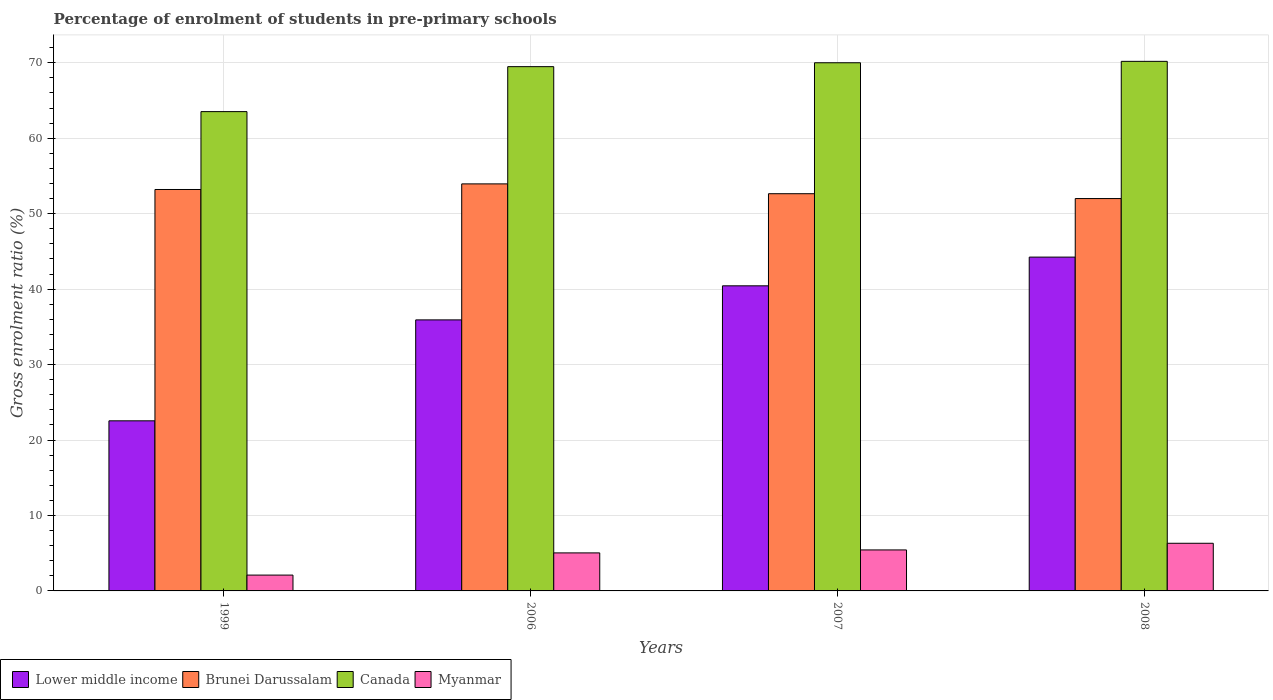How many different coloured bars are there?
Make the answer very short. 4. Are the number of bars per tick equal to the number of legend labels?
Ensure brevity in your answer.  Yes. Are the number of bars on each tick of the X-axis equal?
Your answer should be very brief. Yes. How many bars are there on the 1st tick from the left?
Keep it short and to the point. 4. In how many cases, is the number of bars for a given year not equal to the number of legend labels?
Make the answer very short. 0. What is the percentage of students enrolled in pre-primary schools in Canada in 2007?
Your answer should be very brief. 70. Across all years, what is the maximum percentage of students enrolled in pre-primary schools in Canada?
Your response must be concise. 70.18. Across all years, what is the minimum percentage of students enrolled in pre-primary schools in Lower middle income?
Make the answer very short. 22.54. In which year was the percentage of students enrolled in pre-primary schools in Canada minimum?
Your answer should be compact. 1999. What is the total percentage of students enrolled in pre-primary schools in Canada in the graph?
Your response must be concise. 273.19. What is the difference between the percentage of students enrolled in pre-primary schools in Lower middle income in 2006 and that in 2007?
Provide a succinct answer. -4.51. What is the difference between the percentage of students enrolled in pre-primary schools in Brunei Darussalam in 2007 and the percentage of students enrolled in pre-primary schools in Lower middle income in 2006?
Offer a terse response. 16.72. What is the average percentage of students enrolled in pre-primary schools in Myanmar per year?
Offer a very short reply. 4.72. In the year 2007, what is the difference between the percentage of students enrolled in pre-primary schools in Brunei Darussalam and percentage of students enrolled in pre-primary schools in Canada?
Keep it short and to the point. -17.35. In how many years, is the percentage of students enrolled in pre-primary schools in Canada greater than 6 %?
Offer a terse response. 4. What is the ratio of the percentage of students enrolled in pre-primary schools in Canada in 1999 to that in 2007?
Provide a succinct answer. 0.91. Is the difference between the percentage of students enrolled in pre-primary schools in Brunei Darussalam in 2007 and 2008 greater than the difference between the percentage of students enrolled in pre-primary schools in Canada in 2007 and 2008?
Give a very brief answer. Yes. What is the difference between the highest and the second highest percentage of students enrolled in pre-primary schools in Lower middle income?
Provide a succinct answer. 3.8. What is the difference between the highest and the lowest percentage of students enrolled in pre-primary schools in Brunei Darussalam?
Your answer should be very brief. 1.94. In how many years, is the percentage of students enrolled in pre-primary schools in Myanmar greater than the average percentage of students enrolled in pre-primary schools in Myanmar taken over all years?
Your response must be concise. 3. Is the sum of the percentage of students enrolled in pre-primary schools in Canada in 2007 and 2008 greater than the maximum percentage of students enrolled in pre-primary schools in Myanmar across all years?
Provide a succinct answer. Yes. Is it the case that in every year, the sum of the percentage of students enrolled in pre-primary schools in Brunei Darussalam and percentage of students enrolled in pre-primary schools in Canada is greater than the sum of percentage of students enrolled in pre-primary schools in Myanmar and percentage of students enrolled in pre-primary schools in Lower middle income?
Your answer should be very brief. No. What does the 4th bar from the left in 2008 represents?
Keep it short and to the point. Myanmar. What does the 2nd bar from the right in 2007 represents?
Provide a short and direct response. Canada. How many bars are there?
Ensure brevity in your answer.  16. Are all the bars in the graph horizontal?
Offer a very short reply. No. What is the difference between two consecutive major ticks on the Y-axis?
Offer a very short reply. 10. Are the values on the major ticks of Y-axis written in scientific E-notation?
Your response must be concise. No. Does the graph contain grids?
Offer a very short reply. Yes. Where does the legend appear in the graph?
Your answer should be very brief. Bottom left. What is the title of the graph?
Keep it short and to the point. Percentage of enrolment of students in pre-primary schools. What is the Gross enrolment ratio (%) of Lower middle income in 1999?
Provide a short and direct response. 22.54. What is the Gross enrolment ratio (%) of Brunei Darussalam in 1999?
Make the answer very short. 53.2. What is the Gross enrolment ratio (%) in Canada in 1999?
Keep it short and to the point. 63.52. What is the Gross enrolment ratio (%) in Myanmar in 1999?
Offer a terse response. 2.1. What is the Gross enrolment ratio (%) in Lower middle income in 2006?
Give a very brief answer. 35.92. What is the Gross enrolment ratio (%) in Brunei Darussalam in 2006?
Your answer should be very brief. 53.94. What is the Gross enrolment ratio (%) in Canada in 2006?
Your response must be concise. 69.48. What is the Gross enrolment ratio (%) of Myanmar in 2006?
Your answer should be compact. 5.04. What is the Gross enrolment ratio (%) of Lower middle income in 2007?
Your answer should be very brief. 40.44. What is the Gross enrolment ratio (%) in Brunei Darussalam in 2007?
Make the answer very short. 52.64. What is the Gross enrolment ratio (%) in Canada in 2007?
Your answer should be compact. 70. What is the Gross enrolment ratio (%) of Myanmar in 2007?
Keep it short and to the point. 5.43. What is the Gross enrolment ratio (%) in Lower middle income in 2008?
Ensure brevity in your answer.  44.24. What is the Gross enrolment ratio (%) of Brunei Darussalam in 2008?
Provide a succinct answer. 52. What is the Gross enrolment ratio (%) in Canada in 2008?
Your answer should be compact. 70.18. What is the Gross enrolment ratio (%) in Myanmar in 2008?
Give a very brief answer. 6.31. Across all years, what is the maximum Gross enrolment ratio (%) of Lower middle income?
Offer a terse response. 44.24. Across all years, what is the maximum Gross enrolment ratio (%) of Brunei Darussalam?
Make the answer very short. 53.94. Across all years, what is the maximum Gross enrolment ratio (%) in Canada?
Your answer should be very brief. 70.18. Across all years, what is the maximum Gross enrolment ratio (%) of Myanmar?
Ensure brevity in your answer.  6.31. Across all years, what is the minimum Gross enrolment ratio (%) in Lower middle income?
Provide a short and direct response. 22.54. Across all years, what is the minimum Gross enrolment ratio (%) of Brunei Darussalam?
Ensure brevity in your answer.  52. Across all years, what is the minimum Gross enrolment ratio (%) of Canada?
Ensure brevity in your answer.  63.52. Across all years, what is the minimum Gross enrolment ratio (%) in Myanmar?
Your answer should be very brief. 2.1. What is the total Gross enrolment ratio (%) in Lower middle income in the graph?
Your answer should be compact. 143.14. What is the total Gross enrolment ratio (%) of Brunei Darussalam in the graph?
Offer a terse response. 211.79. What is the total Gross enrolment ratio (%) in Canada in the graph?
Your answer should be very brief. 273.19. What is the total Gross enrolment ratio (%) in Myanmar in the graph?
Your answer should be compact. 18.89. What is the difference between the Gross enrolment ratio (%) of Lower middle income in 1999 and that in 2006?
Make the answer very short. -13.38. What is the difference between the Gross enrolment ratio (%) of Brunei Darussalam in 1999 and that in 2006?
Make the answer very short. -0.74. What is the difference between the Gross enrolment ratio (%) of Canada in 1999 and that in 2006?
Give a very brief answer. -5.96. What is the difference between the Gross enrolment ratio (%) of Myanmar in 1999 and that in 2006?
Provide a short and direct response. -2.94. What is the difference between the Gross enrolment ratio (%) of Lower middle income in 1999 and that in 2007?
Keep it short and to the point. -17.89. What is the difference between the Gross enrolment ratio (%) of Brunei Darussalam in 1999 and that in 2007?
Offer a terse response. 0.56. What is the difference between the Gross enrolment ratio (%) of Canada in 1999 and that in 2007?
Your answer should be compact. -6.48. What is the difference between the Gross enrolment ratio (%) of Myanmar in 1999 and that in 2007?
Provide a short and direct response. -3.33. What is the difference between the Gross enrolment ratio (%) in Lower middle income in 1999 and that in 2008?
Give a very brief answer. -21.7. What is the difference between the Gross enrolment ratio (%) of Brunei Darussalam in 1999 and that in 2008?
Your response must be concise. 1.2. What is the difference between the Gross enrolment ratio (%) in Canada in 1999 and that in 2008?
Provide a short and direct response. -6.66. What is the difference between the Gross enrolment ratio (%) in Myanmar in 1999 and that in 2008?
Give a very brief answer. -4.21. What is the difference between the Gross enrolment ratio (%) in Lower middle income in 2006 and that in 2007?
Provide a short and direct response. -4.51. What is the difference between the Gross enrolment ratio (%) in Brunei Darussalam in 2006 and that in 2007?
Offer a terse response. 1.3. What is the difference between the Gross enrolment ratio (%) in Canada in 2006 and that in 2007?
Your answer should be very brief. -0.51. What is the difference between the Gross enrolment ratio (%) of Myanmar in 2006 and that in 2007?
Make the answer very short. -0.39. What is the difference between the Gross enrolment ratio (%) of Lower middle income in 2006 and that in 2008?
Keep it short and to the point. -8.32. What is the difference between the Gross enrolment ratio (%) of Brunei Darussalam in 2006 and that in 2008?
Provide a succinct answer. 1.94. What is the difference between the Gross enrolment ratio (%) in Canada in 2006 and that in 2008?
Keep it short and to the point. -0.7. What is the difference between the Gross enrolment ratio (%) of Myanmar in 2006 and that in 2008?
Your response must be concise. -1.27. What is the difference between the Gross enrolment ratio (%) of Lower middle income in 2007 and that in 2008?
Keep it short and to the point. -3.8. What is the difference between the Gross enrolment ratio (%) of Brunei Darussalam in 2007 and that in 2008?
Provide a short and direct response. 0.64. What is the difference between the Gross enrolment ratio (%) in Canada in 2007 and that in 2008?
Make the answer very short. -0.19. What is the difference between the Gross enrolment ratio (%) of Myanmar in 2007 and that in 2008?
Keep it short and to the point. -0.88. What is the difference between the Gross enrolment ratio (%) of Lower middle income in 1999 and the Gross enrolment ratio (%) of Brunei Darussalam in 2006?
Give a very brief answer. -31.4. What is the difference between the Gross enrolment ratio (%) of Lower middle income in 1999 and the Gross enrolment ratio (%) of Canada in 2006?
Offer a terse response. -46.94. What is the difference between the Gross enrolment ratio (%) in Lower middle income in 1999 and the Gross enrolment ratio (%) in Myanmar in 2006?
Provide a short and direct response. 17.5. What is the difference between the Gross enrolment ratio (%) in Brunei Darussalam in 1999 and the Gross enrolment ratio (%) in Canada in 2006?
Your answer should be very brief. -16.28. What is the difference between the Gross enrolment ratio (%) in Brunei Darussalam in 1999 and the Gross enrolment ratio (%) in Myanmar in 2006?
Offer a terse response. 48.16. What is the difference between the Gross enrolment ratio (%) of Canada in 1999 and the Gross enrolment ratio (%) of Myanmar in 2006?
Offer a terse response. 58.48. What is the difference between the Gross enrolment ratio (%) of Lower middle income in 1999 and the Gross enrolment ratio (%) of Brunei Darussalam in 2007?
Give a very brief answer. -30.1. What is the difference between the Gross enrolment ratio (%) in Lower middle income in 1999 and the Gross enrolment ratio (%) in Canada in 2007?
Provide a short and direct response. -47.45. What is the difference between the Gross enrolment ratio (%) of Lower middle income in 1999 and the Gross enrolment ratio (%) of Myanmar in 2007?
Your answer should be very brief. 17.11. What is the difference between the Gross enrolment ratio (%) of Brunei Darussalam in 1999 and the Gross enrolment ratio (%) of Canada in 2007?
Provide a succinct answer. -16.8. What is the difference between the Gross enrolment ratio (%) of Brunei Darussalam in 1999 and the Gross enrolment ratio (%) of Myanmar in 2007?
Your answer should be very brief. 47.77. What is the difference between the Gross enrolment ratio (%) in Canada in 1999 and the Gross enrolment ratio (%) in Myanmar in 2007?
Provide a succinct answer. 58.09. What is the difference between the Gross enrolment ratio (%) in Lower middle income in 1999 and the Gross enrolment ratio (%) in Brunei Darussalam in 2008?
Your answer should be compact. -29.46. What is the difference between the Gross enrolment ratio (%) of Lower middle income in 1999 and the Gross enrolment ratio (%) of Canada in 2008?
Your answer should be very brief. -47.64. What is the difference between the Gross enrolment ratio (%) in Lower middle income in 1999 and the Gross enrolment ratio (%) in Myanmar in 2008?
Provide a short and direct response. 16.23. What is the difference between the Gross enrolment ratio (%) of Brunei Darussalam in 1999 and the Gross enrolment ratio (%) of Canada in 2008?
Offer a terse response. -16.98. What is the difference between the Gross enrolment ratio (%) in Brunei Darussalam in 1999 and the Gross enrolment ratio (%) in Myanmar in 2008?
Offer a terse response. 46.89. What is the difference between the Gross enrolment ratio (%) in Canada in 1999 and the Gross enrolment ratio (%) in Myanmar in 2008?
Make the answer very short. 57.21. What is the difference between the Gross enrolment ratio (%) in Lower middle income in 2006 and the Gross enrolment ratio (%) in Brunei Darussalam in 2007?
Your response must be concise. -16.72. What is the difference between the Gross enrolment ratio (%) of Lower middle income in 2006 and the Gross enrolment ratio (%) of Canada in 2007?
Ensure brevity in your answer.  -34.08. What is the difference between the Gross enrolment ratio (%) in Lower middle income in 2006 and the Gross enrolment ratio (%) in Myanmar in 2007?
Offer a terse response. 30.49. What is the difference between the Gross enrolment ratio (%) in Brunei Darussalam in 2006 and the Gross enrolment ratio (%) in Canada in 2007?
Provide a succinct answer. -16.05. What is the difference between the Gross enrolment ratio (%) in Brunei Darussalam in 2006 and the Gross enrolment ratio (%) in Myanmar in 2007?
Keep it short and to the point. 48.51. What is the difference between the Gross enrolment ratio (%) in Canada in 2006 and the Gross enrolment ratio (%) in Myanmar in 2007?
Give a very brief answer. 64.05. What is the difference between the Gross enrolment ratio (%) of Lower middle income in 2006 and the Gross enrolment ratio (%) of Brunei Darussalam in 2008?
Your answer should be compact. -16.08. What is the difference between the Gross enrolment ratio (%) of Lower middle income in 2006 and the Gross enrolment ratio (%) of Canada in 2008?
Make the answer very short. -34.26. What is the difference between the Gross enrolment ratio (%) in Lower middle income in 2006 and the Gross enrolment ratio (%) in Myanmar in 2008?
Provide a succinct answer. 29.61. What is the difference between the Gross enrolment ratio (%) of Brunei Darussalam in 2006 and the Gross enrolment ratio (%) of Canada in 2008?
Your answer should be compact. -16.24. What is the difference between the Gross enrolment ratio (%) in Brunei Darussalam in 2006 and the Gross enrolment ratio (%) in Myanmar in 2008?
Offer a very short reply. 47.63. What is the difference between the Gross enrolment ratio (%) of Canada in 2006 and the Gross enrolment ratio (%) of Myanmar in 2008?
Ensure brevity in your answer.  63.17. What is the difference between the Gross enrolment ratio (%) in Lower middle income in 2007 and the Gross enrolment ratio (%) in Brunei Darussalam in 2008?
Make the answer very short. -11.56. What is the difference between the Gross enrolment ratio (%) in Lower middle income in 2007 and the Gross enrolment ratio (%) in Canada in 2008?
Make the answer very short. -29.75. What is the difference between the Gross enrolment ratio (%) in Lower middle income in 2007 and the Gross enrolment ratio (%) in Myanmar in 2008?
Provide a succinct answer. 34.12. What is the difference between the Gross enrolment ratio (%) in Brunei Darussalam in 2007 and the Gross enrolment ratio (%) in Canada in 2008?
Your answer should be compact. -17.54. What is the difference between the Gross enrolment ratio (%) in Brunei Darussalam in 2007 and the Gross enrolment ratio (%) in Myanmar in 2008?
Provide a short and direct response. 46.33. What is the difference between the Gross enrolment ratio (%) of Canada in 2007 and the Gross enrolment ratio (%) of Myanmar in 2008?
Your response must be concise. 63.68. What is the average Gross enrolment ratio (%) of Lower middle income per year?
Offer a very short reply. 35.79. What is the average Gross enrolment ratio (%) in Brunei Darussalam per year?
Your answer should be compact. 52.95. What is the average Gross enrolment ratio (%) of Canada per year?
Ensure brevity in your answer.  68.3. What is the average Gross enrolment ratio (%) in Myanmar per year?
Give a very brief answer. 4.72. In the year 1999, what is the difference between the Gross enrolment ratio (%) of Lower middle income and Gross enrolment ratio (%) of Brunei Darussalam?
Offer a very short reply. -30.66. In the year 1999, what is the difference between the Gross enrolment ratio (%) of Lower middle income and Gross enrolment ratio (%) of Canada?
Your answer should be compact. -40.98. In the year 1999, what is the difference between the Gross enrolment ratio (%) in Lower middle income and Gross enrolment ratio (%) in Myanmar?
Make the answer very short. 20.44. In the year 1999, what is the difference between the Gross enrolment ratio (%) of Brunei Darussalam and Gross enrolment ratio (%) of Canada?
Provide a short and direct response. -10.32. In the year 1999, what is the difference between the Gross enrolment ratio (%) of Brunei Darussalam and Gross enrolment ratio (%) of Myanmar?
Your answer should be very brief. 51.1. In the year 1999, what is the difference between the Gross enrolment ratio (%) in Canada and Gross enrolment ratio (%) in Myanmar?
Offer a very short reply. 61.42. In the year 2006, what is the difference between the Gross enrolment ratio (%) in Lower middle income and Gross enrolment ratio (%) in Brunei Darussalam?
Give a very brief answer. -18.02. In the year 2006, what is the difference between the Gross enrolment ratio (%) in Lower middle income and Gross enrolment ratio (%) in Canada?
Keep it short and to the point. -33.56. In the year 2006, what is the difference between the Gross enrolment ratio (%) in Lower middle income and Gross enrolment ratio (%) in Myanmar?
Offer a terse response. 30.88. In the year 2006, what is the difference between the Gross enrolment ratio (%) in Brunei Darussalam and Gross enrolment ratio (%) in Canada?
Keep it short and to the point. -15.54. In the year 2006, what is the difference between the Gross enrolment ratio (%) of Brunei Darussalam and Gross enrolment ratio (%) of Myanmar?
Provide a succinct answer. 48.91. In the year 2006, what is the difference between the Gross enrolment ratio (%) in Canada and Gross enrolment ratio (%) in Myanmar?
Give a very brief answer. 64.44. In the year 2007, what is the difference between the Gross enrolment ratio (%) of Lower middle income and Gross enrolment ratio (%) of Brunei Darussalam?
Keep it short and to the point. -12.21. In the year 2007, what is the difference between the Gross enrolment ratio (%) in Lower middle income and Gross enrolment ratio (%) in Canada?
Offer a very short reply. -29.56. In the year 2007, what is the difference between the Gross enrolment ratio (%) in Lower middle income and Gross enrolment ratio (%) in Myanmar?
Give a very brief answer. 35. In the year 2007, what is the difference between the Gross enrolment ratio (%) of Brunei Darussalam and Gross enrolment ratio (%) of Canada?
Provide a short and direct response. -17.35. In the year 2007, what is the difference between the Gross enrolment ratio (%) in Brunei Darussalam and Gross enrolment ratio (%) in Myanmar?
Offer a terse response. 47.21. In the year 2007, what is the difference between the Gross enrolment ratio (%) of Canada and Gross enrolment ratio (%) of Myanmar?
Provide a short and direct response. 64.56. In the year 2008, what is the difference between the Gross enrolment ratio (%) of Lower middle income and Gross enrolment ratio (%) of Brunei Darussalam?
Offer a very short reply. -7.76. In the year 2008, what is the difference between the Gross enrolment ratio (%) in Lower middle income and Gross enrolment ratio (%) in Canada?
Offer a terse response. -25.94. In the year 2008, what is the difference between the Gross enrolment ratio (%) of Lower middle income and Gross enrolment ratio (%) of Myanmar?
Offer a terse response. 37.93. In the year 2008, what is the difference between the Gross enrolment ratio (%) of Brunei Darussalam and Gross enrolment ratio (%) of Canada?
Provide a succinct answer. -18.18. In the year 2008, what is the difference between the Gross enrolment ratio (%) in Brunei Darussalam and Gross enrolment ratio (%) in Myanmar?
Keep it short and to the point. 45.69. In the year 2008, what is the difference between the Gross enrolment ratio (%) in Canada and Gross enrolment ratio (%) in Myanmar?
Your answer should be compact. 63.87. What is the ratio of the Gross enrolment ratio (%) in Lower middle income in 1999 to that in 2006?
Provide a succinct answer. 0.63. What is the ratio of the Gross enrolment ratio (%) in Brunei Darussalam in 1999 to that in 2006?
Provide a succinct answer. 0.99. What is the ratio of the Gross enrolment ratio (%) of Canada in 1999 to that in 2006?
Keep it short and to the point. 0.91. What is the ratio of the Gross enrolment ratio (%) in Myanmar in 1999 to that in 2006?
Your response must be concise. 0.42. What is the ratio of the Gross enrolment ratio (%) in Lower middle income in 1999 to that in 2007?
Your answer should be compact. 0.56. What is the ratio of the Gross enrolment ratio (%) of Brunei Darussalam in 1999 to that in 2007?
Your response must be concise. 1.01. What is the ratio of the Gross enrolment ratio (%) in Canada in 1999 to that in 2007?
Provide a short and direct response. 0.91. What is the ratio of the Gross enrolment ratio (%) of Myanmar in 1999 to that in 2007?
Make the answer very short. 0.39. What is the ratio of the Gross enrolment ratio (%) in Lower middle income in 1999 to that in 2008?
Your answer should be very brief. 0.51. What is the ratio of the Gross enrolment ratio (%) in Brunei Darussalam in 1999 to that in 2008?
Provide a succinct answer. 1.02. What is the ratio of the Gross enrolment ratio (%) in Canada in 1999 to that in 2008?
Your answer should be compact. 0.91. What is the ratio of the Gross enrolment ratio (%) of Myanmar in 1999 to that in 2008?
Ensure brevity in your answer.  0.33. What is the ratio of the Gross enrolment ratio (%) of Lower middle income in 2006 to that in 2007?
Ensure brevity in your answer.  0.89. What is the ratio of the Gross enrolment ratio (%) in Brunei Darussalam in 2006 to that in 2007?
Your response must be concise. 1.02. What is the ratio of the Gross enrolment ratio (%) of Canada in 2006 to that in 2007?
Your answer should be very brief. 0.99. What is the ratio of the Gross enrolment ratio (%) in Myanmar in 2006 to that in 2007?
Make the answer very short. 0.93. What is the ratio of the Gross enrolment ratio (%) of Lower middle income in 2006 to that in 2008?
Your answer should be very brief. 0.81. What is the ratio of the Gross enrolment ratio (%) in Brunei Darussalam in 2006 to that in 2008?
Provide a succinct answer. 1.04. What is the ratio of the Gross enrolment ratio (%) in Myanmar in 2006 to that in 2008?
Make the answer very short. 0.8. What is the ratio of the Gross enrolment ratio (%) of Lower middle income in 2007 to that in 2008?
Ensure brevity in your answer.  0.91. What is the ratio of the Gross enrolment ratio (%) of Brunei Darussalam in 2007 to that in 2008?
Give a very brief answer. 1.01. What is the ratio of the Gross enrolment ratio (%) in Canada in 2007 to that in 2008?
Provide a succinct answer. 1. What is the ratio of the Gross enrolment ratio (%) of Myanmar in 2007 to that in 2008?
Ensure brevity in your answer.  0.86. What is the difference between the highest and the second highest Gross enrolment ratio (%) of Lower middle income?
Offer a very short reply. 3.8. What is the difference between the highest and the second highest Gross enrolment ratio (%) in Brunei Darussalam?
Your answer should be very brief. 0.74. What is the difference between the highest and the second highest Gross enrolment ratio (%) of Canada?
Your answer should be compact. 0.19. What is the difference between the highest and the second highest Gross enrolment ratio (%) of Myanmar?
Ensure brevity in your answer.  0.88. What is the difference between the highest and the lowest Gross enrolment ratio (%) of Lower middle income?
Your response must be concise. 21.7. What is the difference between the highest and the lowest Gross enrolment ratio (%) in Brunei Darussalam?
Your answer should be very brief. 1.94. What is the difference between the highest and the lowest Gross enrolment ratio (%) of Canada?
Provide a succinct answer. 6.66. What is the difference between the highest and the lowest Gross enrolment ratio (%) of Myanmar?
Offer a very short reply. 4.21. 